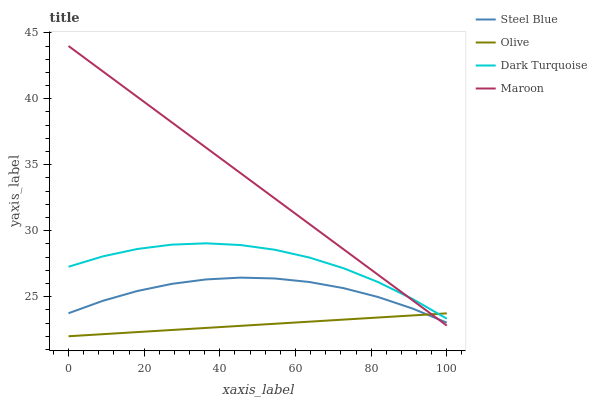Does Olive have the minimum area under the curve?
Answer yes or no. Yes. Does Maroon have the maximum area under the curve?
Answer yes or no. Yes. Does Dark Turquoise have the minimum area under the curve?
Answer yes or no. No. Does Dark Turquoise have the maximum area under the curve?
Answer yes or no. No. Is Olive the smoothest?
Answer yes or no. Yes. Is Dark Turquoise the roughest?
Answer yes or no. Yes. Is Steel Blue the smoothest?
Answer yes or no. No. Is Steel Blue the roughest?
Answer yes or no. No. Does Olive have the lowest value?
Answer yes or no. Yes. Does Steel Blue have the lowest value?
Answer yes or no. No. Does Maroon have the highest value?
Answer yes or no. Yes. Does Dark Turquoise have the highest value?
Answer yes or no. No. Is Steel Blue less than Dark Turquoise?
Answer yes or no. Yes. Is Dark Turquoise greater than Steel Blue?
Answer yes or no. Yes. Does Maroon intersect Steel Blue?
Answer yes or no. Yes. Is Maroon less than Steel Blue?
Answer yes or no. No. Is Maroon greater than Steel Blue?
Answer yes or no. No. Does Steel Blue intersect Dark Turquoise?
Answer yes or no. No. 